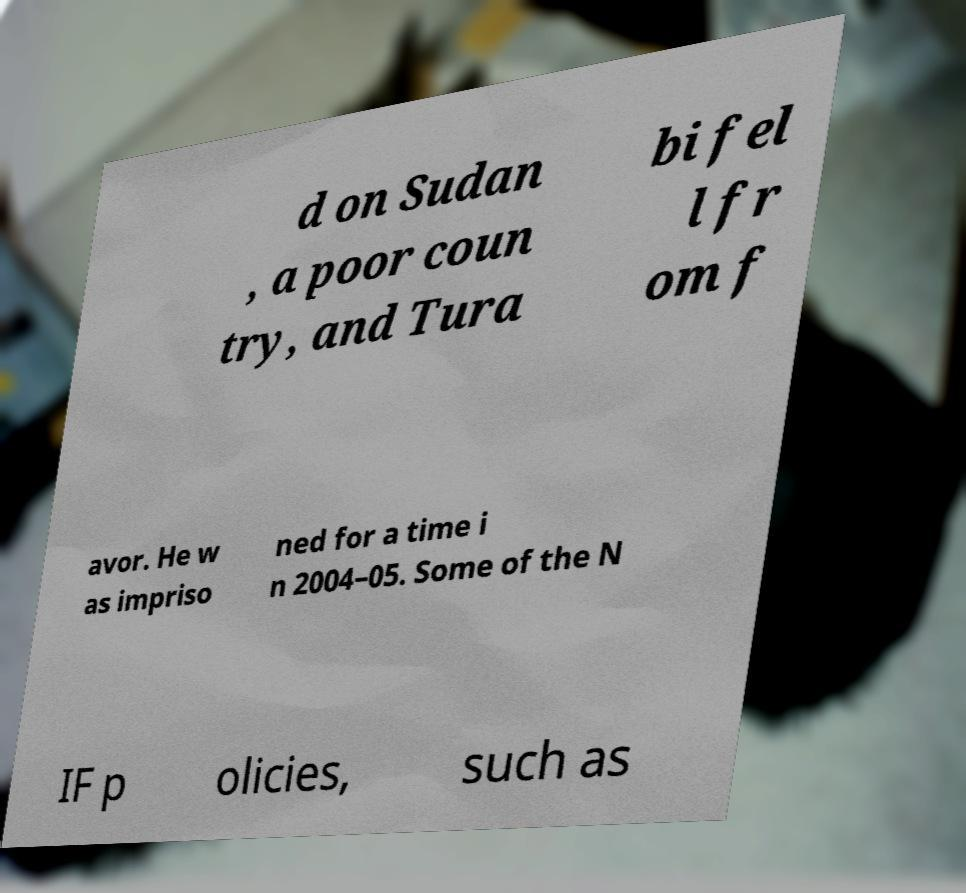I need the written content from this picture converted into text. Can you do that? d on Sudan , a poor coun try, and Tura bi fel l fr om f avor. He w as impriso ned for a time i n 2004–05. Some of the N IF p olicies, such as 